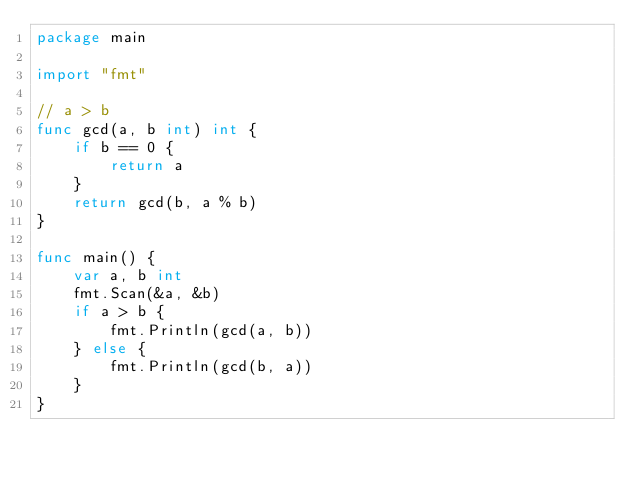Convert code to text. <code><loc_0><loc_0><loc_500><loc_500><_Go_>package main

import "fmt"

// a > b
func gcd(a, b int) int {
	if b == 0 {
		return a
	}
	return gcd(b, a % b)
}

func main() {
	var a, b int
	fmt.Scan(&a, &b)
	if a > b {
		fmt.Println(gcd(a, b))
	} else {
		fmt.Println(gcd(b, a))
	}
}

</code> 